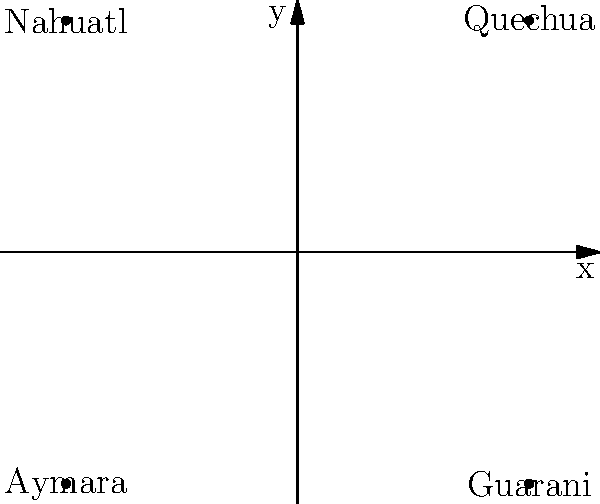In which quadrant of the coordinate plane is Quechua, an indigenous language of South America, most commonly spoken according to the diagram? To determine the quadrant where Quechua is most commonly spoken, we need to follow these steps:

1. Recall the quadrants of a coordinate plane:
   - Quadrant I: positive x, positive y (top right)
   - Quadrant II: negative x, positive y (top left)
   - Quadrant III: negative x, negative y (bottom left)
   - Quadrant IV: positive x, negative y (bottom right)

2. Locate Quechua on the coordinate plane:
   - Quechua is positioned in the top right section of the plane.

3. Identify the coordinates:
   - Quechua is in the area where both x and y are positive.

4. Determine the quadrant:
   - Positive x and positive y correspond to Quadrant I.

Therefore, Quechua is most commonly spoken in Quadrant I of the coordinate plane.
Answer: Quadrant I 